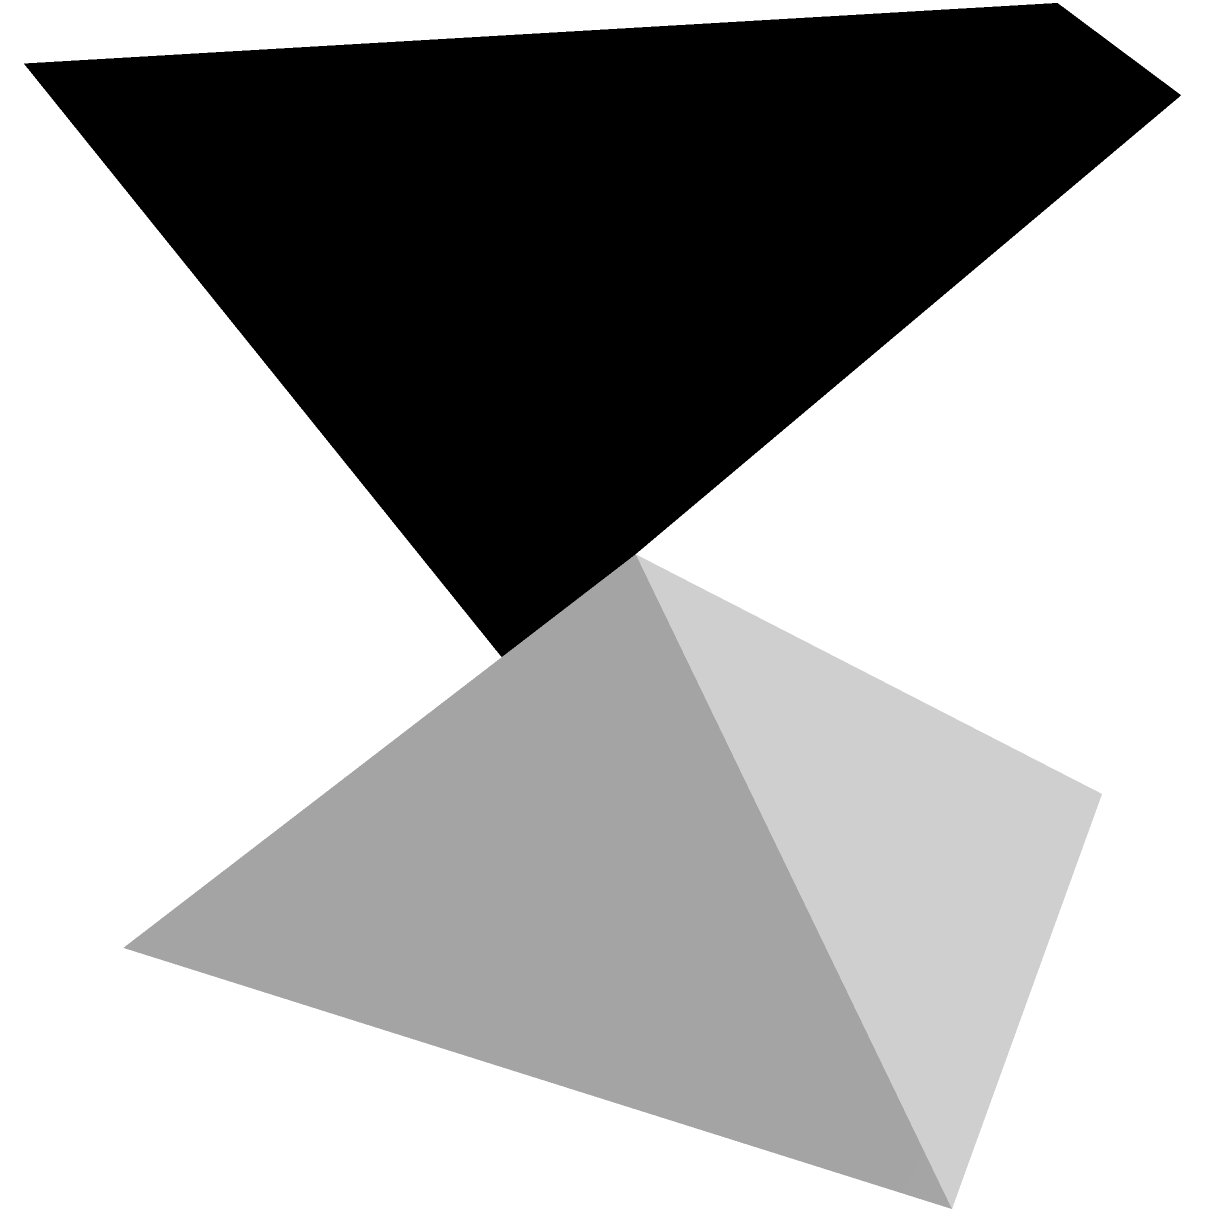A uniquely designed acoustic panel for a concert hall has a rectangular base measuring 2m by 1m and a height of 1.5m. The top surface is curved and described by the function $z = 1.5(1-0.5\sin(\pi x)\sin(\pi y))$, where $0 \leq x \leq 2$ and $0 \leq y \leq 1$. Calculate the total surface area of this acoustic panel to ensure optimal sound reflection properties. To find the total surface area, we need to calculate and sum the areas of all surfaces:

1. Area of the base (rectangle): $A_{base} = 2 \times 1 = 2$ m²

2. Area of the four vertical sides:
   - Two sides: $2 \times (2 \times 1.5) = 6$ m²
   - Two sides: $2 \times (1 \times 1.5) = 3$ m²
   Total vertical area: $6 + 3 = 9$ m²

3. Area of the curved top surface:
   We need to use the surface area formula for a parametric surface:
   $$A = \int_0^1 \int_0^2 \sqrt{1 + (\frac{\partial z}{\partial x})^2 + (\frac{\partial z}{\partial y})^2} \, dx \, dy$$

   Where:
   $$\frac{\partial z}{\partial x} = -0.75\pi \cos(\pi x)\sin(\pi y)$$
   $$\frac{\partial z}{\partial y} = -0.75\pi \sin(\pi x)\cos(\pi y)$$

   This integral cannot be solved analytically, so we need to use numerical integration.
   Using a computational tool, we find that the area of the curved surface is approximately 2.3815 m²

4. Total surface area:
   $A_{total} = A_{base} + A_{vertical} + A_{curved}$
   $A_{total} = 2 + 9 + 2.3815 = 13.3815$ m²
Answer: 13.3815 m² 